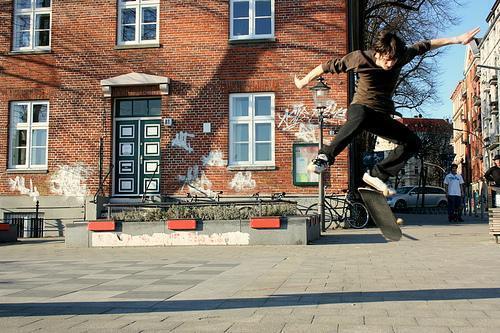How many windows are shown on the building to the left?
Give a very brief answer. 5. 